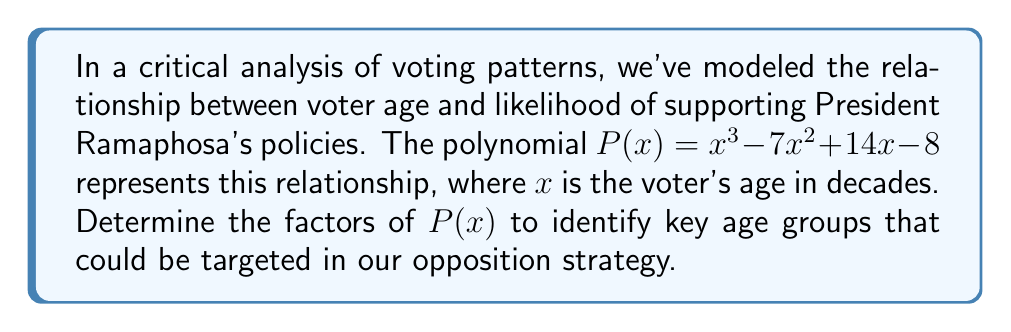Can you answer this question? Let's approach this step-by-step:

1) First, we'll try to identify if there are any rational roots using the rational root theorem. The possible rational roots are the factors of the constant term: $\pm 1, \pm 2, \pm 4, \pm 8$.

2) Testing these values, we find that $P(1) = 0$. So $(x-1)$ is a factor.

3) We can use polynomial long division to divide $P(x)$ by $(x-1)$:

   $$\frac{x^3 - 7x^2 + 14x - 8}{x-1} = x^2 - 6x + 8$$

4) Now we need to factor the quadratic $x^2 - 6x + 8$. We can do this by finding two numbers that multiply to give 8 and add to give -6. These numbers are -2 and -4.

5) Therefore, $x^2 - 6x + 8 = (x-2)(x-4)$

6) Combining all factors, we get:

   $$P(x) = (x-1)(x-2)(x-4)$$

This factorization reveals that the key age groups are 10 years (1 decade), 20 years (2 decades), and 40 years (4 decades). These represent potential pivot points in voting behavior that our opposition strategy could target.
Answer: $(x-1)(x-2)(x-4)$ 